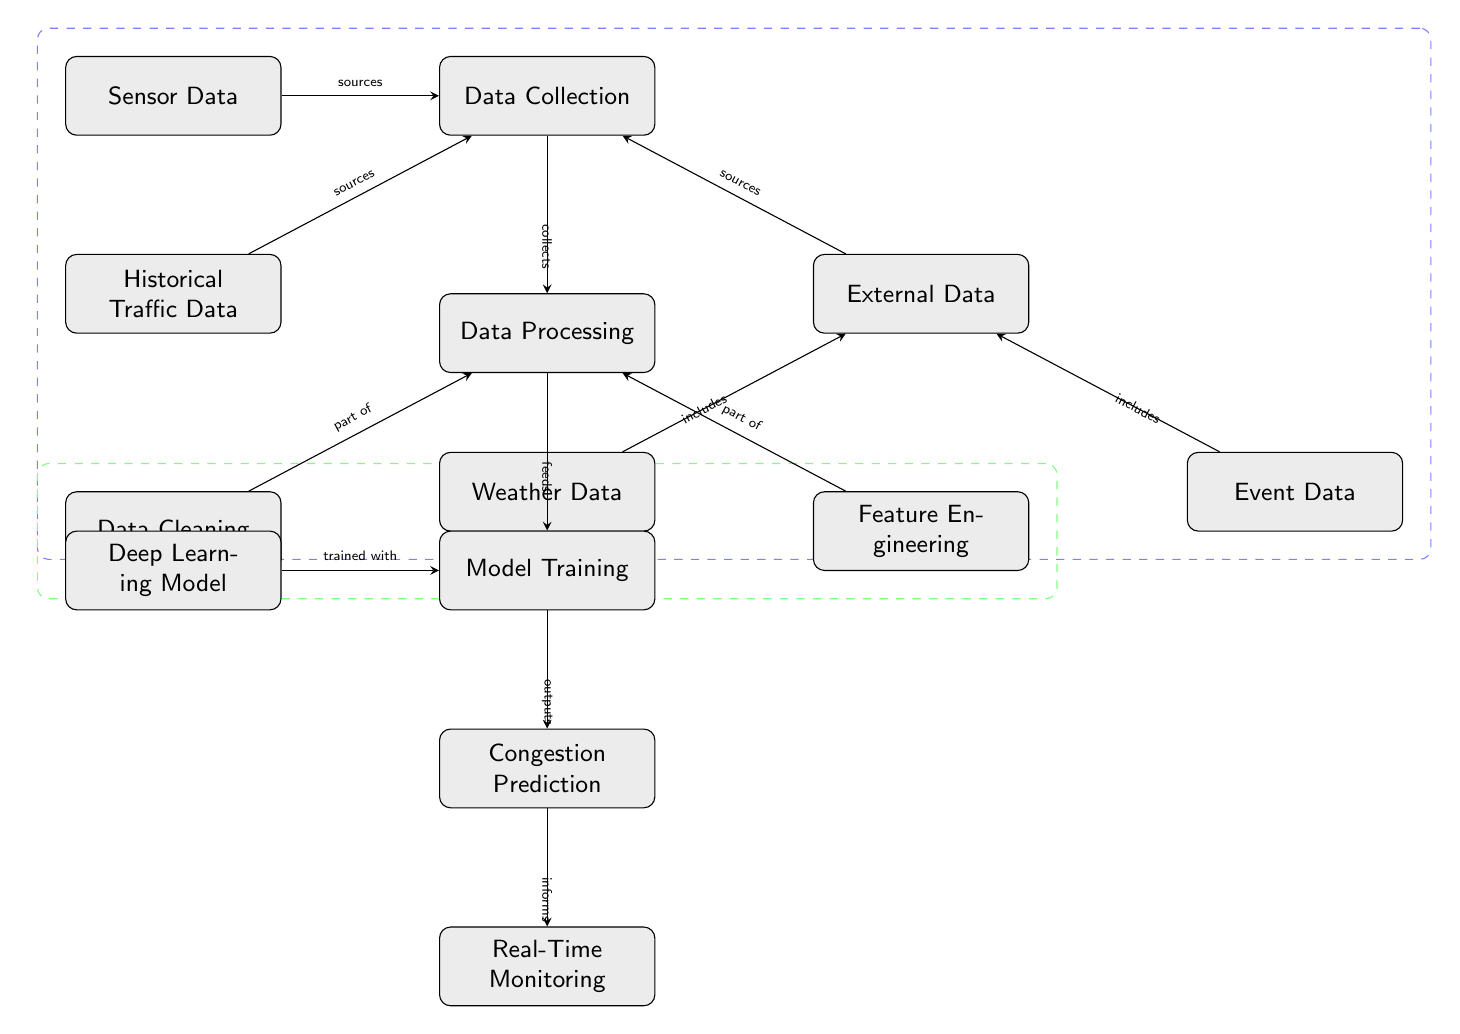What is the first step in the diagram? The first step is "Data Collection," which is at the top of the diagram. This defines the initial phase of the predictive process.
Answer: Data Collection How many types of data sources are shown? There are three primary types of data sources indicated in the diagram: Historical Traffic Data, Sensor Data, and External Data. Each category has specific components or sources.
Answer: Three What is the relationship between Data Cleaning and Data Processing? Data Cleaning is a part of the Data Processing stage, indicating that cleaning is an essential operation performed within the broader data processing task.
Answer: Part of Which nodes are included within the External Data category? The External Data category includes two nodes: Weather Data and Event Data. These contribute to the overall external context for traffic predictions.
Answer: Weather Data and Event Data What does the Deep Learning Model feed into? The Deep Learning Model feeds into the Model Training phase, meaning it is the component trained based on the processed data to recognize patterns.
Answer: Model Training What informs Real-Time Monitoring? The Congestion Prediction is what informs the Real-Time Monitoring, implying that the predictions on congestion influence the monitoring process.
Answer: Congestion Prediction Which process is indicated as essential before Model Training? Data Processing must occur before Model Training, as it prepares the data and features needed for effective training of the model.
Answer: Data Processing What kind of data does the diagram illustrate as being collected? The diagram illustrates multiple types of data collected: Historical Traffic Data, Sensor Data, and External Data, indicating a comprehensive approach to data gathering for predictions.
Answer: Historical Traffic Data, Sensor Data, and External Data Which step includes the activities of cleaning data and feature engineering? The Data Processing step includes both data cleaning and feature engineering, indicating that these activities are integral to preparing data for subsequent analysis.
Answer: Data Processing 